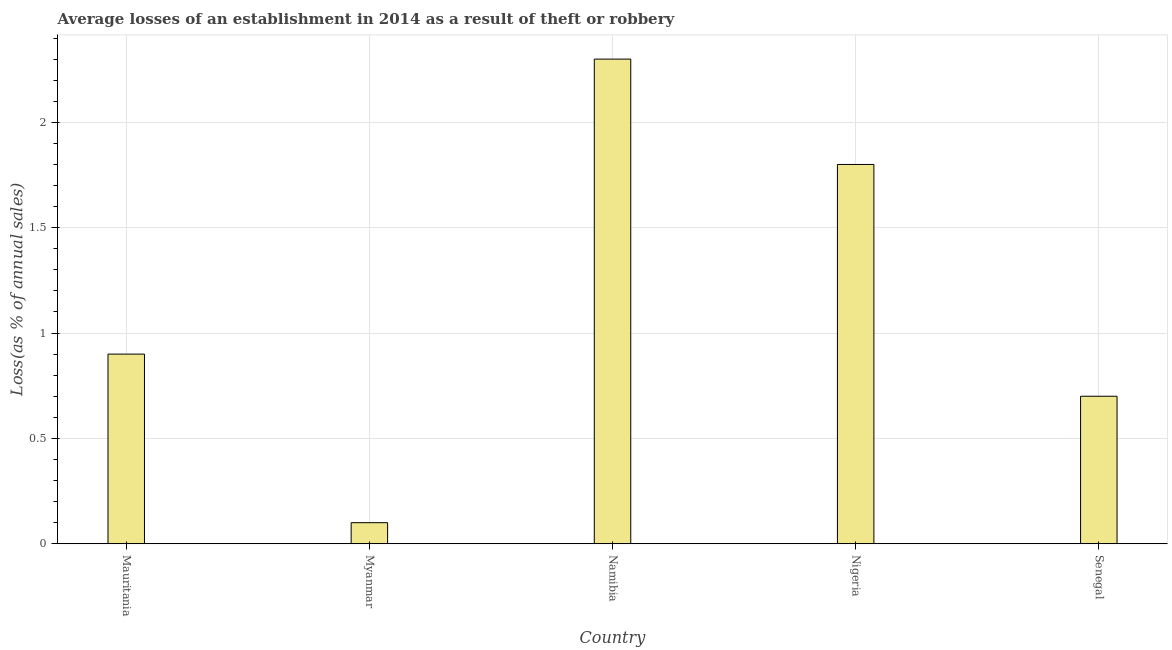Does the graph contain grids?
Offer a very short reply. Yes. What is the title of the graph?
Keep it short and to the point. Average losses of an establishment in 2014 as a result of theft or robbery. What is the label or title of the X-axis?
Make the answer very short. Country. What is the label or title of the Y-axis?
Make the answer very short. Loss(as % of annual sales). What is the losses due to theft in Mauritania?
Give a very brief answer. 0.9. In which country was the losses due to theft maximum?
Give a very brief answer. Namibia. In which country was the losses due to theft minimum?
Your response must be concise. Myanmar. What is the average losses due to theft per country?
Provide a succinct answer. 1.16. In how many countries, is the losses due to theft greater than 0.2 %?
Provide a short and direct response. 4. What is the ratio of the losses due to theft in Mauritania to that in Nigeria?
Provide a succinct answer. 0.5. Is the losses due to theft in Myanmar less than that in Namibia?
Make the answer very short. Yes. Is the difference between the losses due to theft in Myanmar and Senegal greater than the difference between any two countries?
Your response must be concise. No. In how many countries, is the losses due to theft greater than the average losses due to theft taken over all countries?
Provide a short and direct response. 2. Are all the bars in the graph horizontal?
Your answer should be compact. No. How many countries are there in the graph?
Ensure brevity in your answer.  5. What is the difference between two consecutive major ticks on the Y-axis?
Your response must be concise. 0.5. Are the values on the major ticks of Y-axis written in scientific E-notation?
Provide a succinct answer. No. What is the Loss(as % of annual sales) in Mauritania?
Keep it short and to the point. 0.9. What is the Loss(as % of annual sales) in Nigeria?
Your answer should be very brief. 1.8. What is the difference between the Loss(as % of annual sales) in Mauritania and Myanmar?
Offer a terse response. 0.8. What is the difference between the Loss(as % of annual sales) in Mauritania and Senegal?
Your answer should be very brief. 0.2. What is the difference between the Loss(as % of annual sales) in Myanmar and Senegal?
Offer a very short reply. -0.6. What is the difference between the Loss(as % of annual sales) in Namibia and Nigeria?
Make the answer very short. 0.5. What is the difference between the Loss(as % of annual sales) in Nigeria and Senegal?
Your answer should be compact. 1.1. What is the ratio of the Loss(as % of annual sales) in Mauritania to that in Myanmar?
Your answer should be compact. 9. What is the ratio of the Loss(as % of annual sales) in Mauritania to that in Namibia?
Give a very brief answer. 0.39. What is the ratio of the Loss(as % of annual sales) in Mauritania to that in Nigeria?
Your answer should be compact. 0.5. What is the ratio of the Loss(as % of annual sales) in Mauritania to that in Senegal?
Ensure brevity in your answer.  1.29. What is the ratio of the Loss(as % of annual sales) in Myanmar to that in Namibia?
Provide a short and direct response. 0.04. What is the ratio of the Loss(as % of annual sales) in Myanmar to that in Nigeria?
Offer a very short reply. 0.06. What is the ratio of the Loss(as % of annual sales) in Myanmar to that in Senegal?
Make the answer very short. 0.14. What is the ratio of the Loss(as % of annual sales) in Namibia to that in Nigeria?
Offer a very short reply. 1.28. What is the ratio of the Loss(as % of annual sales) in Namibia to that in Senegal?
Provide a short and direct response. 3.29. What is the ratio of the Loss(as % of annual sales) in Nigeria to that in Senegal?
Your response must be concise. 2.57. 